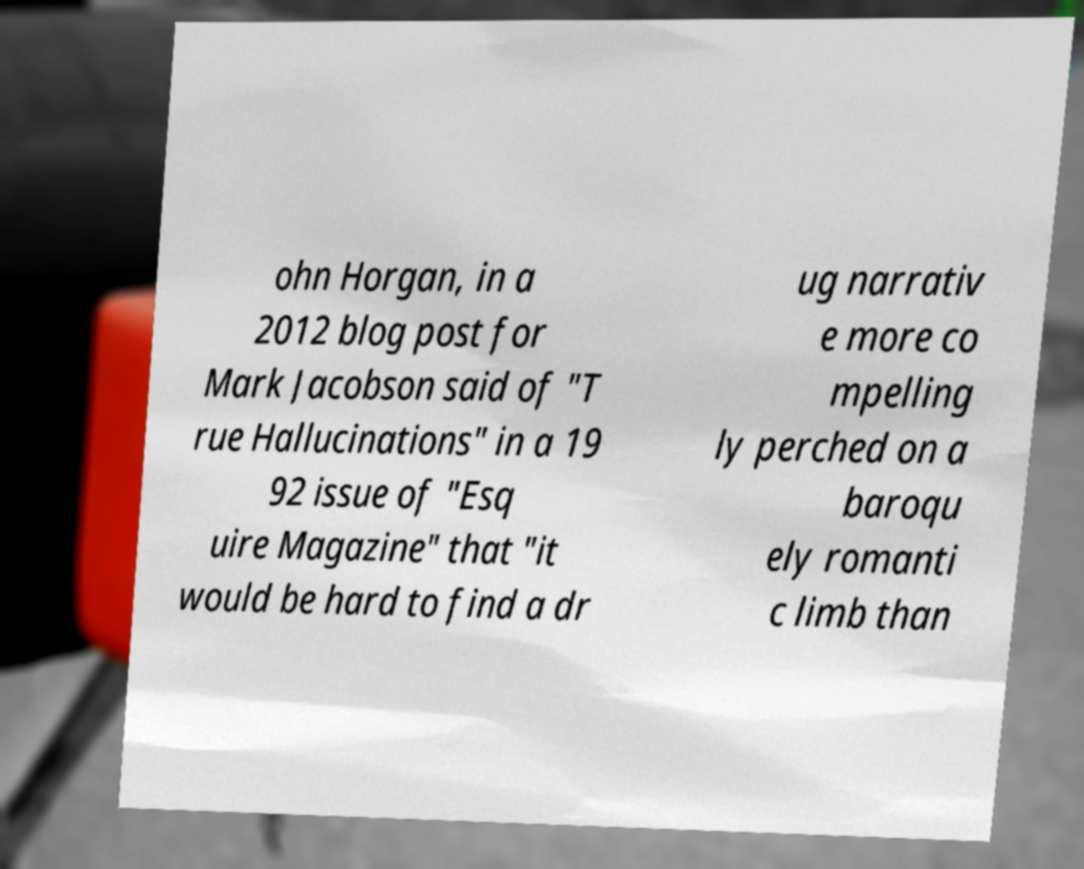I need the written content from this picture converted into text. Can you do that? ohn Horgan, in a 2012 blog post for Mark Jacobson said of "T rue Hallucinations" in a 19 92 issue of "Esq uire Magazine" that "it would be hard to find a dr ug narrativ e more co mpelling ly perched on a baroqu ely romanti c limb than 